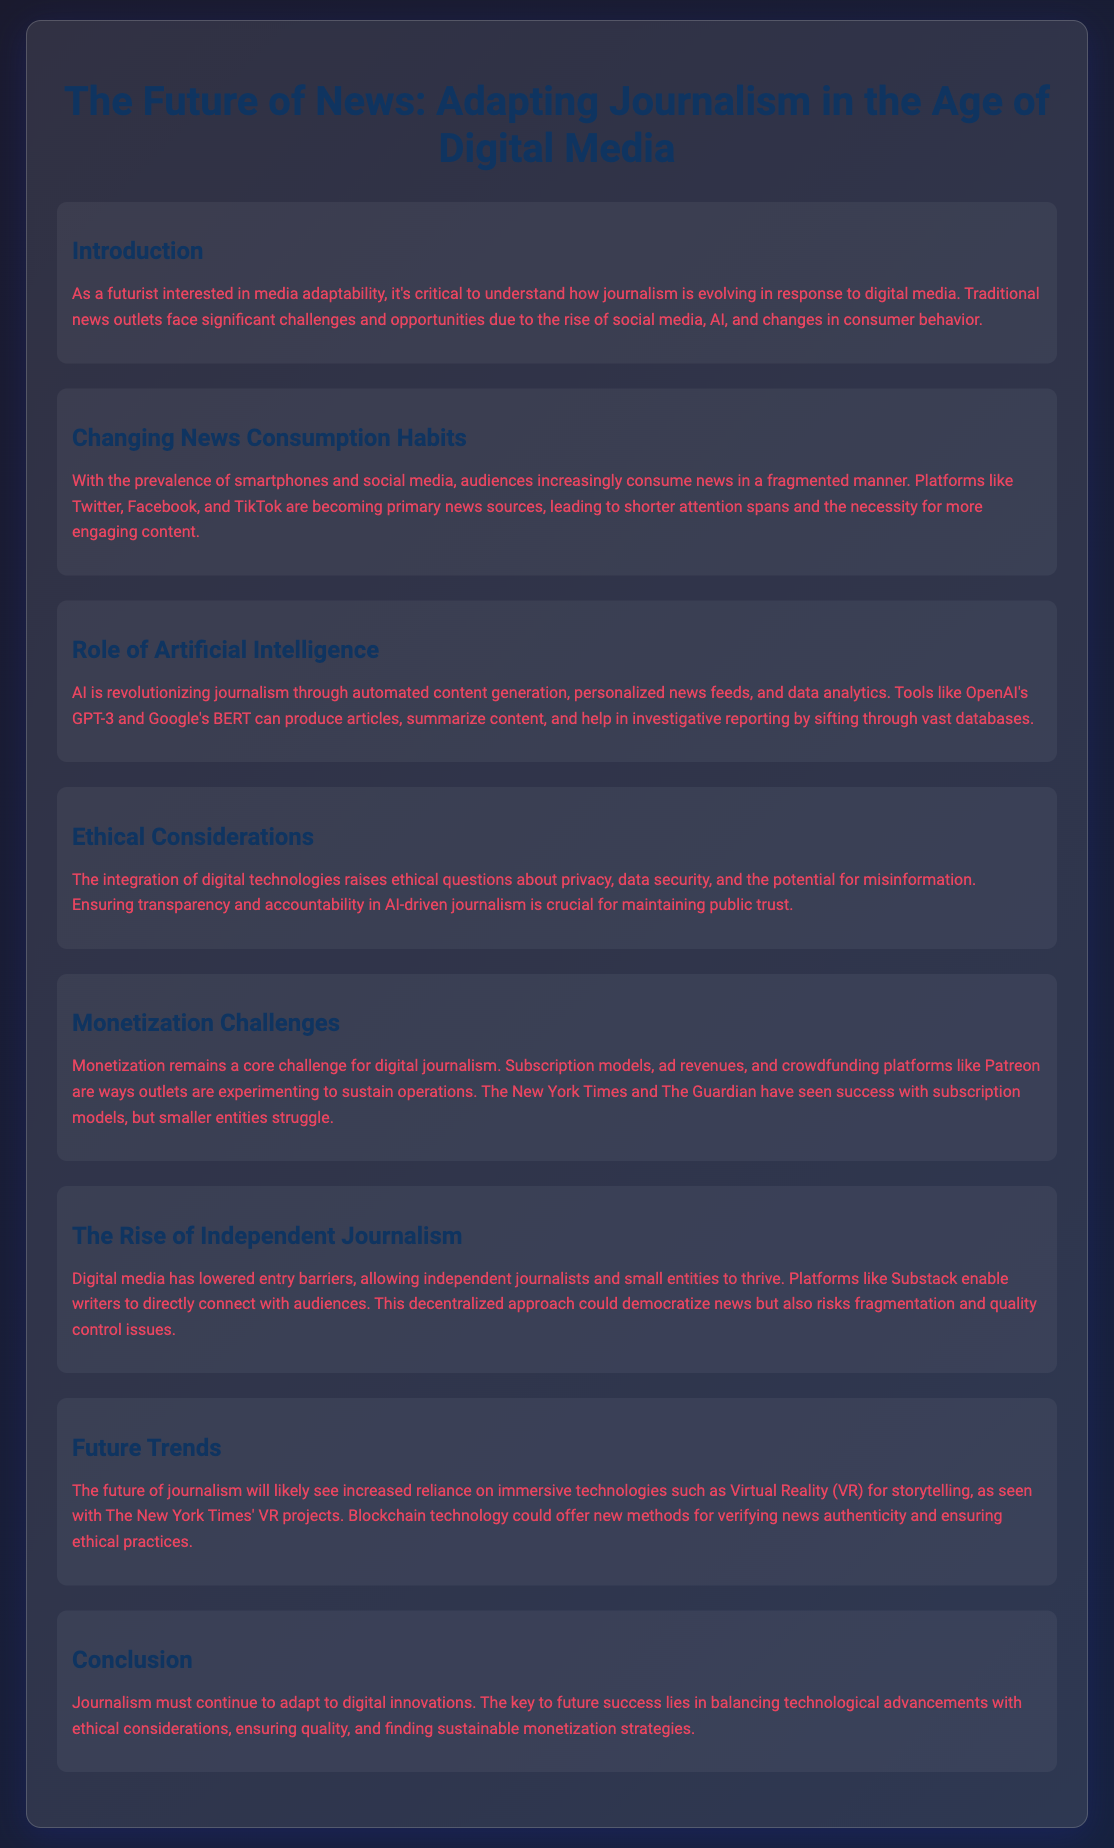What is the title of the presentation? The title of the presentation is the main heading found at the top of the document.
Answer: The Future of News: Adapting Journalism in the Age of Digital Media What are the main platforms mentioned for news consumption? The platforms highlighted in the document as primary news sources include social media platforms.
Answer: Twitter, Facebook, and TikTok What is one tool mentioned that is revolutionizing journalism? The document lists specific AI tools that are impacting journalism practices.
Answer: OpenAI's GPT-3 What challenge is mentioned related to digital journalism? The document discusses issues specific to sustaining journalistic practices in the digital age.
Answer: Monetization What opportunity does digital media provide for independent journalists? The document states the advantage of digital media for smaller entities and individual journalists.
Answer: Lowered entry barriers What is a future technology mentioned for storytelling in journalism? The document describes emerging technologies that may enhance journalistic storytelling methods.
Answer: Virtual Reality (VR) What ethical consideration is emphasized in AI-driven journalism? The document underlines a critical aspect that affects public perception and trust in journalism.
Answer: Transparency Which news outlet is mentioned as having success with subscription models? The document refers to a specific well-known news organization that has embraced subscription strategies effectively.
Answer: The New York Times What future trend involves verifying news authenticity? The document illustrates potential innovative solutions to ensure reliability in news reporting.
Answer: Blockchain technology 